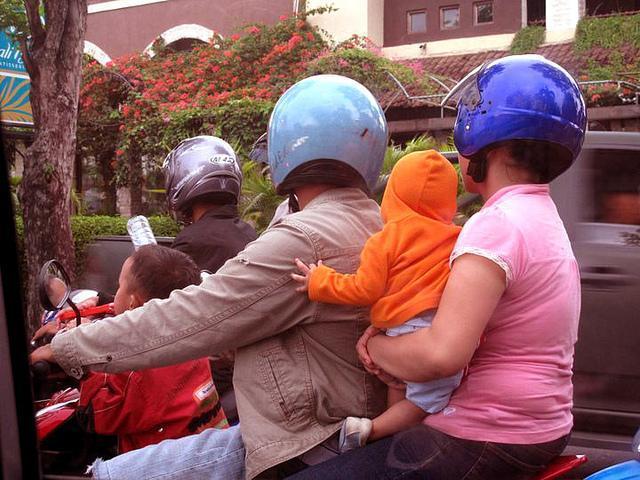How many helmets are there?
Give a very brief answer. 3. How many people are on the bike?
Give a very brief answer. 4. How many people are in the picture?
Give a very brief answer. 5. How many motorcycles are there?
Give a very brief answer. 2. How many oranges are in the picture?
Give a very brief answer. 0. 